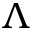Convert formula to latex. <formula><loc_0><loc_0><loc_500><loc_500>\Lambda</formula> 